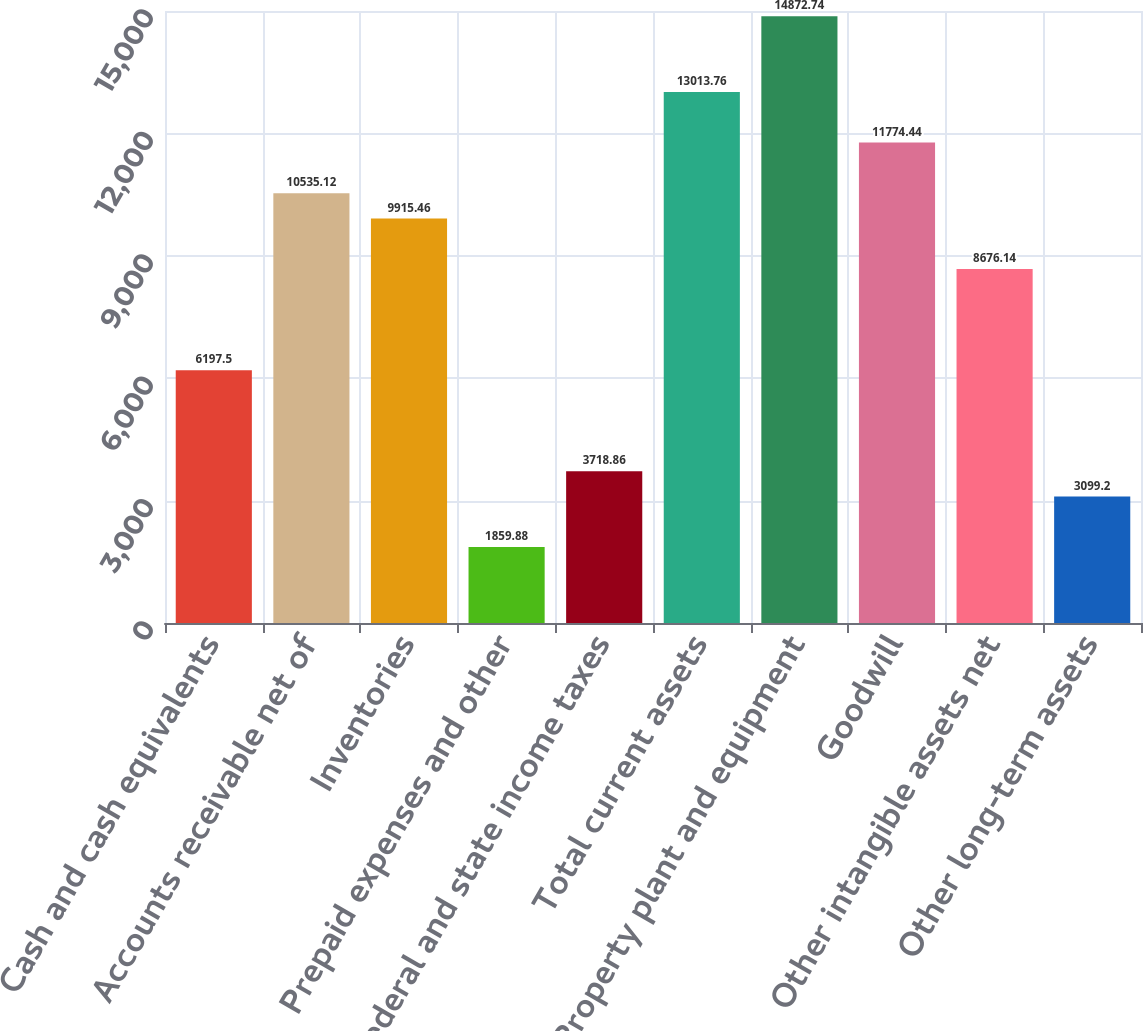Convert chart. <chart><loc_0><loc_0><loc_500><loc_500><bar_chart><fcel>Cash and cash equivalents<fcel>Accounts receivable net of<fcel>Inventories<fcel>Prepaid expenses and other<fcel>Federal and state income taxes<fcel>Total current assets<fcel>Property plant and equipment<fcel>Goodwill<fcel>Other intangible assets net<fcel>Other long-term assets<nl><fcel>6197.5<fcel>10535.1<fcel>9915.46<fcel>1859.88<fcel>3718.86<fcel>13013.8<fcel>14872.7<fcel>11774.4<fcel>8676.14<fcel>3099.2<nl></chart> 